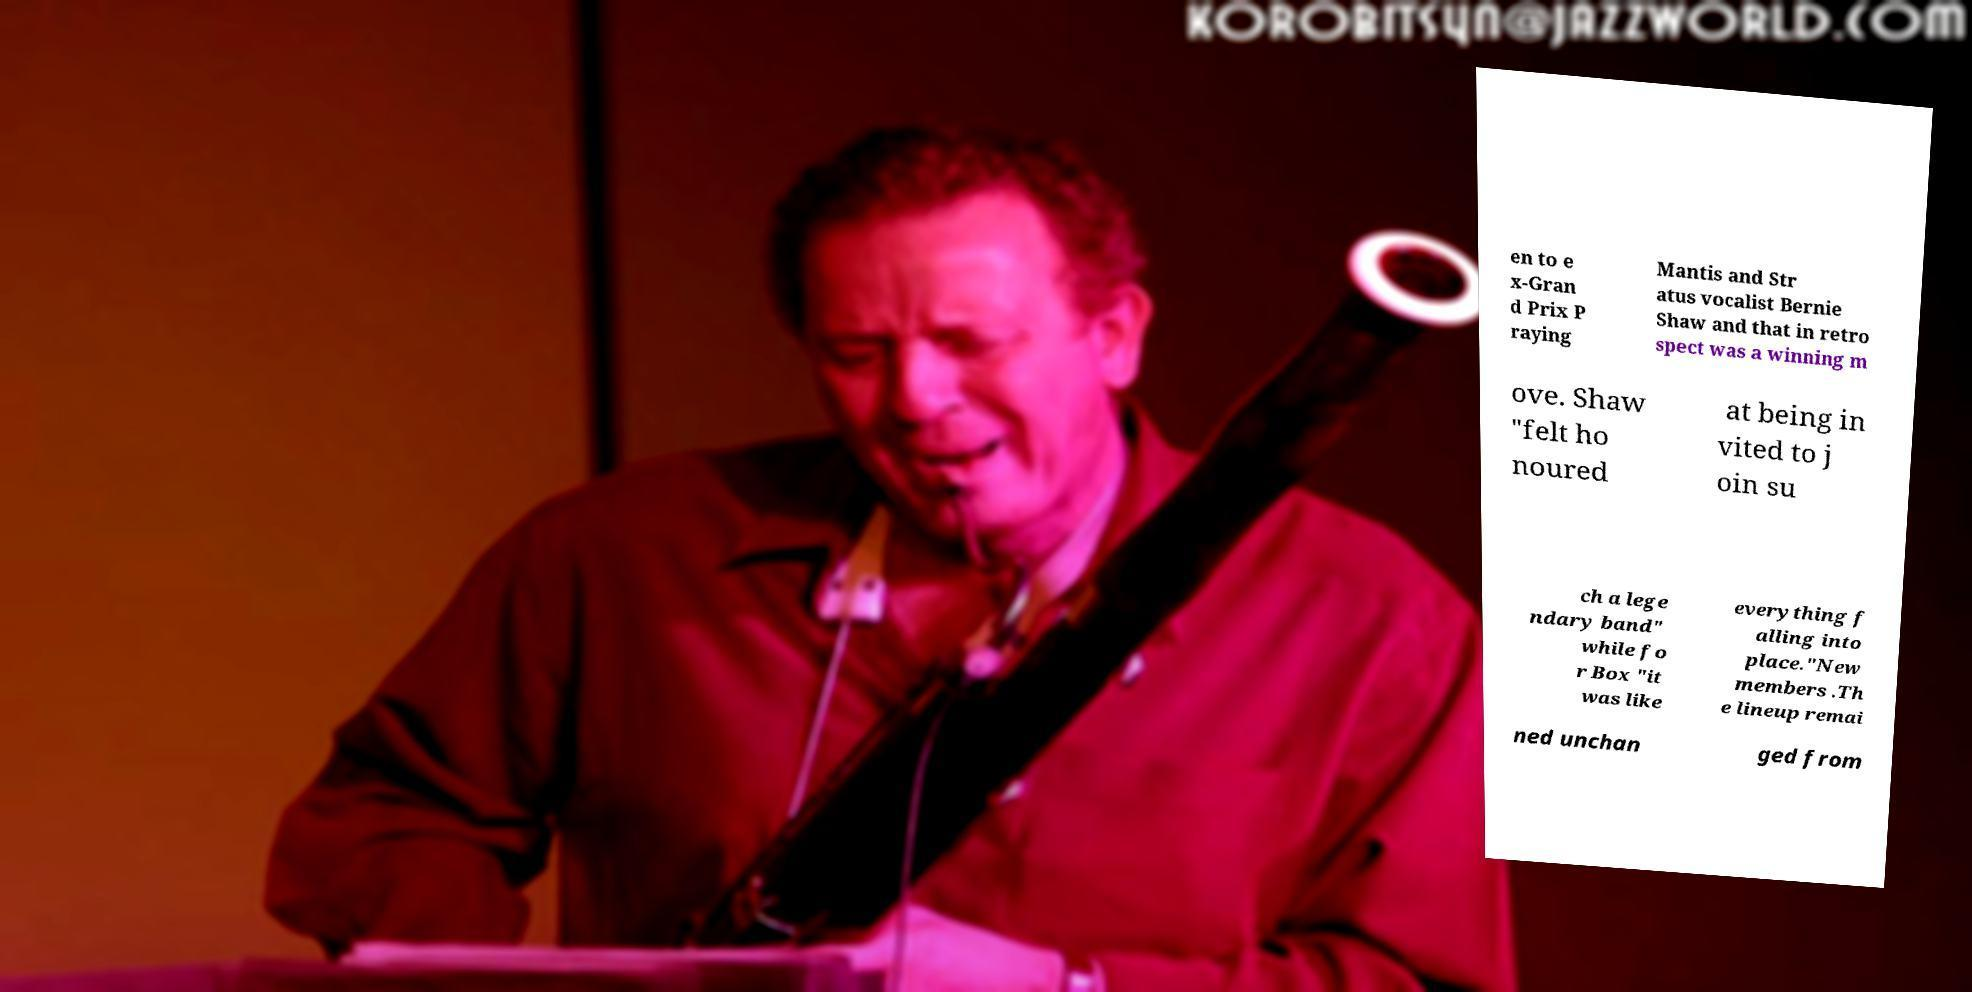What messages or text are displayed in this image? I need them in a readable, typed format. en to e x-Gran d Prix P raying Mantis and Str atus vocalist Bernie Shaw and that in retro spect was a winning m ove. Shaw "felt ho noured at being in vited to j oin su ch a lege ndary band" while fo r Box "it was like everything f alling into place."New members .Th e lineup remai ned unchan ged from 